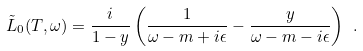<formula> <loc_0><loc_0><loc_500><loc_500>\tilde { L } _ { 0 } ( T , \omega ) = \frac { i } { 1 - y } \left ( \frac { 1 } { \omega - m + i \epsilon } - \frac { y } { \omega - m - i \epsilon } \right ) \ .</formula> 